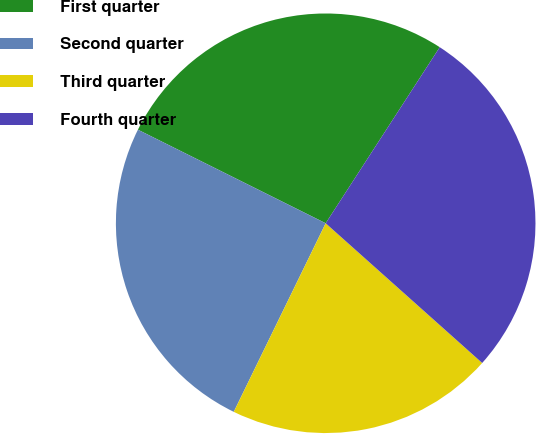Convert chart. <chart><loc_0><loc_0><loc_500><loc_500><pie_chart><fcel>First quarter<fcel>Second quarter<fcel>Third quarter<fcel>Fourth quarter<nl><fcel>26.79%<fcel>25.14%<fcel>20.62%<fcel>27.45%<nl></chart> 